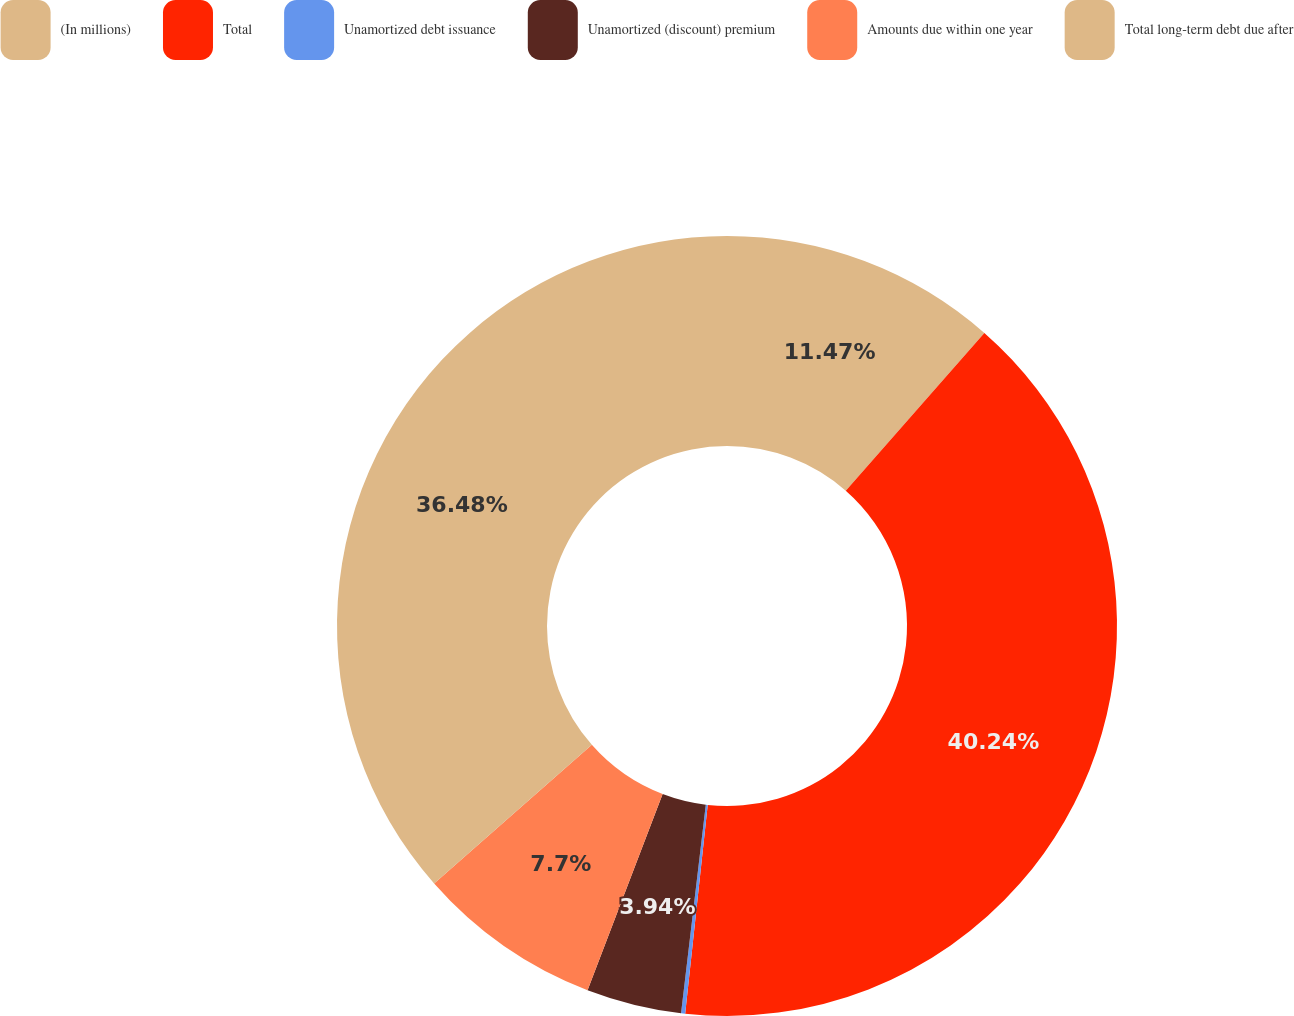Convert chart. <chart><loc_0><loc_0><loc_500><loc_500><pie_chart><fcel>(In millions)<fcel>Total<fcel>Unamortized debt issuance<fcel>Unamortized (discount) premium<fcel>Amounts due within one year<fcel>Total long-term debt due after<nl><fcel>11.47%<fcel>40.24%<fcel>0.17%<fcel>3.94%<fcel>7.7%<fcel>36.48%<nl></chart> 